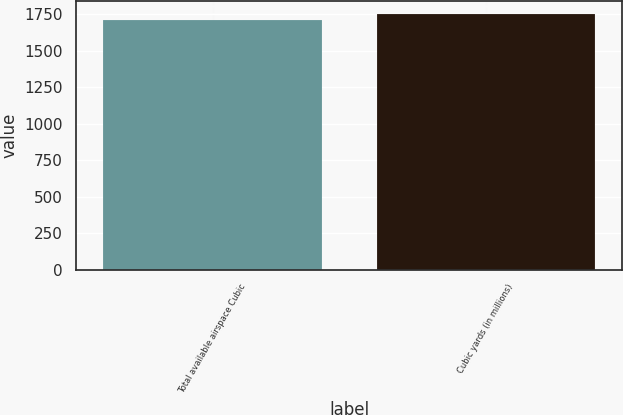<chart> <loc_0><loc_0><loc_500><loc_500><bar_chart><fcel>Total available airspace Cubic<fcel>Cubic yards (in millions)<nl><fcel>1711.2<fcel>1751.8<nl></chart> 